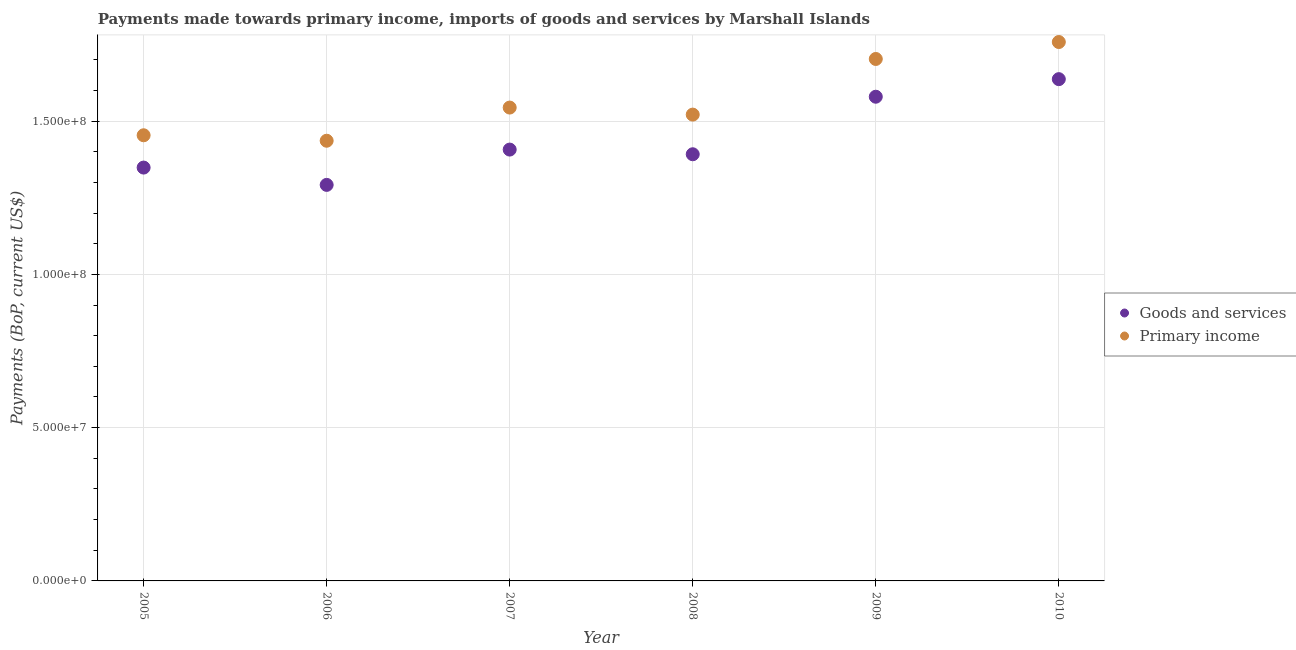How many different coloured dotlines are there?
Your answer should be compact. 2. What is the payments made towards primary income in 2010?
Keep it short and to the point. 1.76e+08. Across all years, what is the maximum payments made towards primary income?
Your answer should be very brief. 1.76e+08. Across all years, what is the minimum payments made towards primary income?
Make the answer very short. 1.44e+08. In which year was the payments made towards goods and services minimum?
Provide a short and direct response. 2006. What is the total payments made towards primary income in the graph?
Provide a succinct answer. 9.41e+08. What is the difference between the payments made towards goods and services in 2005 and that in 2007?
Keep it short and to the point. -5.87e+06. What is the difference between the payments made towards goods and services in 2010 and the payments made towards primary income in 2006?
Offer a very short reply. 2.01e+07. What is the average payments made towards goods and services per year?
Keep it short and to the point. 1.44e+08. In the year 2010, what is the difference between the payments made towards primary income and payments made towards goods and services?
Provide a short and direct response. 1.21e+07. In how many years, is the payments made towards primary income greater than 160000000 US$?
Make the answer very short. 2. What is the ratio of the payments made towards primary income in 2008 to that in 2009?
Give a very brief answer. 0.89. Is the payments made towards primary income in 2007 less than that in 2009?
Offer a very short reply. Yes. What is the difference between the highest and the second highest payments made towards goods and services?
Give a very brief answer. 5.73e+06. What is the difference between the highest and the lowest payments made towards goods and services?
Your response must be concise. 3.45e+07. In how many years, is the payments made towards primary income greater than the average payments made towards primary income taken over all years?
Give a very brief answer. 2. Is the sum of the payments made towards goods and services in 2008 and 2009 greater than the maximum payments made towards primary income across all years?
Give a very brief answer. Yes. Is the payments made towards primary income strictly less than the payments made towards goods and services over the years?
Ensure brevity in your answer.  No. How many dotlines are there?
Your answer should be very brief. 2. Are the values on the major ticks of Y-axis written in scientific E-notation?
Make the answer very short. Yes. Does the graph contain any zero values?
Give a very brief answer. No. Where does the legend appear in the graph?
Make the answer very short. Center right. How are the legend labels stacked?
Keep it short and to the point. Vertical. What is the title of the graph?
Give a very brief answer. Payments made towards primary income, imports of goods and services by Marshall Islands. Does "Investment" appear as one of the legend labels in the graph?
Your answer should be compact. No. What is the label or title of the X-axis?
Provide a short and direct response. Year. What is the label or title of the Y-axis?
Keep it short and to the point. Payments (BoP, current US$). What is the Payments (BoP, current US$) in Goods and services in 2005?
Offer a terse response. 1.35e+08. What is the Payments (BoP, current US$) in Primary income in 2005?
Your answer should be very brief. 1.45e+08. What is the Payments (BoP, current US$) of Goods and services in 2006?
Your answer should be very brief. 1.29e+08. What is the Payments (BoP, current US$) of Primary income in 2006?
Give a very brief answer. 1.44e+08. What is the Payments (BoP, current US$) in Goods and services in 2007?
Offer a terse response. 1.41e+08. What is the Payments (BoP, current US$) of Primary income in 2007?
Your response must be concise. 1.54e+08. What is the Payments (BoP, current US$) in Goods and services in 2008?
Provide a short and direct response. 1.39e+08. What is the Payments (BoP, current US$) in Primary income in 2008?
Give a very brief answer. 1.52e+08. What is the Payments (BoP, current US$) of Goods and services in 2009?
Offer a terse response. 1.58e+08. What is the Payments (BoP, current US$) in Primary income in 2009?
Your answer should be very brief. 1.70e+08. What is the Payments (BoP, current US$) of Goods and services in 2010?
Provide a short and direct response. 1.64e+08. What is the Payments (BoP, current US$) of Primary income in 2010?
Ensure brevity in your answer.  1.76e+08. Across all years, what is the maximum Payments (BoP, current US$) in Goods and services?
Keep it short and to the point. 1.64e+08. Across all years, what is the maximum Payments (BoP, current US$) of Primary income?
Ensure brevity in your answer.  1.76e+08. Across all years, what is the minimum Payments (BoP, current US$) of Goods and services?
Make the answer very short. 1.29e+08. Across all years, what is the minimum Payments (BoP, current US$) of Primary income?
Your answer should be compact. 1.44e+08. What is the total Payments (BoP, current US$) of Goods and services in the graph?
Offer a very short reply. 8.65e+08. What is the total Payments (BoP, current US$) in Primary income in the graph?
Offer a terse response. 9.41e+08. What is the difference between the Payments (BoP, current US$) of Goods and services in 2005 and that in 2006?
Provide a short and direct response. 5.65e+06. What is the difference between the Payments (BoP, current US$) of Primary income in 2005 and that in 2006?
Your response must be concise. 1.78e+06. What is the difference between the Payments (BoP, current US$) of Goods and services in 2005 and that in 2007?
Offer a terse response. -5.87e+06. What is the difference between the Payments (BoP, current US$) of Primary income in 2005 and that in 2007?
Provide a succinct answer. -9.04e+06. What is the difference between the Payments (BoP, current US$) of Goods and services in 2005 and that in 2008?
Offer a very short reply. -4.35e+06. What is the difference between the Payments (BoP, current US$) in Primary income in 2005 and that in 2008?
Your response must be concise. -6.74e+06. What is the difference between the Payments (BoP, current US$) of Goods and services in 2005 and that in 2009?
Keep it short and to the point. -2.31e+07. What is the difference between the Payments (BoP, current US$) of Primary income in 2005 and that in 2009?
Provide a succinct answer. -2.49e+07. What is the difference between the Payments (BoP, current US$) in Goods and services in 2005 and that in 2010?
Make the answer very short. -2.88e+07. What is the difference between the Payments (BoP, current US$) in Primary income in 2005 and that in 2010?
Keep it short and to the point. -3.04e+07. What is the difference between the Payments (BoP, current US$) in Goods and services in 2006 and that in 2007?
Your response must be concise. -1.15e+07. What is the difference between the Payments (BoP, current US$) in Primary income in 2006 and that in 2007?
Ensure brevity in your answer.  -1.08e+07. What is the difference between the Payments (BoP, current US$) in Goods and services in 2006 and that in 2008?
Keep it short and to the point. -9.99e+06. What is the difference between the Payments (BoP, current US$) of Primary income in 2006 and that in 2008?
Make the answer very short. -8.53e+06. What is the difference between the Payments (BoP, current US$) of Goods and services in 2006 and that in 2009?
Your response must be concise. -2.88e+07. What is the difference between the Payments (BoP, current US$) of Primary income in 2006 and that in 2009?
Offer a terse response. -2.67e+07. What is the difference between the Payments (BoP, current US$) in Goods and services in 2006 and that in 2010?
Ensure brevity in your answer.  -3.45e+07. What is the difference between the Payments (BoP, current US$) in Primary income in 2006 and that in 2010?
Ensure brevity in your answer.  -3.22e+07. What is the difference between the Payments (BoP, current US$) of Goods and services in 2007 and that in 2008?
Ensure brevity in your answer.  1.53e+06. What is the difference between the Payments (BoP, current US$) in Primary income in 2007 and that in 2008?
Ensure brevity in your answer.  2.30e+06. What is the difference between the Payments (BoP, current US$) of Goods and services in 2007 and that in 2009?
Provide a short and direct response. -1.72e+07. What is the difference between the Payments (BoP, current US$) of Primary income in 2007 and that in 2009?
Your answer should be very brief. -1.59e+07. What is the difference between the Payments (BoP, current US$) of Goods and services in 2007 and that in 2010?
Your response must be concise. -2.30e+07. What is the difference between the Payments (BoP, current US$) of Primary income in 2007 and that in 2010?
Your answer should be very brief. -2.14e+07. What is the difference between the Payments (BoP, current US$) in Goods and services in 2008 and that in 2009?
Make the answer very short. -1.88e+07. What is the difference between the Payments (BoP, current US$) of Primary income in 2008 and that in 2009?
Make the answer very short. -1.81e+07. What is the difference between the Payments (BoP, current US$) in Goods and services in 2008 and that in 2010?
Offer a very short reply. -2.45e+07. What is the difference between the Payments (BoP, current US$) of Primary income in 2008 and that in 2010?
Your answer should be very brief. -2.37e+07. What is the difference between the Payments (BoP, current US$) in Goods and services in 2009 and that in 2010?
Keep it short and to the point. -5.73e+06. What is the difference between the Payments (BoP, current US$) in Primary income in 2009 and that in 2010?
Your answer should be very brief. -5.53e+06. What is the difference between the Payments (BoP, current US$) of Goods and services in 2005 and the Payments (BoP, current US$) of Primary income in 2006?
Your answer should be compact. -8.75e+06. What is the difference between the Payments (BoP, current US$) of Goods and services in 2005 and the Payments (BoP, current US$) of Primary income in 2007?
Ensure brevity in your answer.  -1.96e+07. What is the difference between the Payments (BoP, current US$) of Goods and services in 2005 and the Payments (BoP, current US$) of Primary income in 2008?
Give a very brief answer. -1.73e+07. What is the difference between the Payments (BoP, current US$) in Goods and services in 2005 and the Payments (BoP, current US$) in Primary income in 2009?
Give a very brief answer. -3.54e+07. What is the difference between the Payments (BoP, current US$) in Goods and services in 2005 and the Payments (BoP, current US$) in Primary income in 2010?
Your answer should be compact. -4.10e+07. What is the difference between the Payments (BoP, current US$) in Goods and services in 2006 and the Payments (BoP, current US$) in Primary income in 2007?
Offer a very short reply. -2.52e+07. What is the difference between the Payments (BoP, current US$) in Goods and services in 2006 and the Payments (BoP, current US$) in Primary income in 2008?
Provide a short and direct response. -2.29e+07. What is the difference between the Payments (BoP, current US$) in Goods and services in 2006 and the Payments (BoP, current US$) in Primary income in 2009?
Make the answer very short. -4.11e+07. What is the difference between the Payments (BoP, current US$) of Goods and services in 2006 and the Payments (BoP, current US$) of Primary income in 2010?
Provide a succinct answer. -4.66e+07. What is the difference between the Payments (BoP, current US$) of Goods and services in 2007 and the Payments (BoP, current US$) of Primary income in 2008?
Keep it short and to the point. -1.14e+07. What is the difference between the Payments (BoP, current US$) in Goods and services in 2007 and the Payments (BoP, current US$) in Primary income in 2009?
Your answer should be very brief. -2.96e+07. What is the difference between the Payments (BoP, current US$) of Goods and services in 2007 and the Payments (BoP, current US$) of Primary income in 2010?
Your response must be concise. -3.51e+07. What is the difference between the Payments (BoP, current US$) in Goods and services in 2008 and the Payments (BoP, current US$) in Primary income in 2009?
Your answer should be very brief. -3.11e+07. What is the difference between the Payments (BoP, current US$) of Goods and services in 2008 and the Payments (BoP, current US$) of Primary income in 2010?
Offer a very short reply. -3.66e+07. What is the difference between the Payments (BoP, current US$) of Goods and services in 2009 and the Payments (BoP, current US$) of Primary income in 2010?
Provide a short and direct response. -1.78e+07. What is the average Payments (BoP, current US$) in Goods and services per year?
Your answer should be very brief. 1.44e+08. What is the average Payments (BoP, current US$) in Primary income per year?
Ensure brevity in your answer.  1.57e+08. In the year 2005, what is the difference between the Payments (BoP, current US$) in Goods and services and Payments (BoP, current US$) in Primary income?
Provide a short and direct response. -1.05e+07. In the year 2006, what is the difference between the Payments (BoP, current US$) of Goods and services and Payments (BoP, current US$) of Primary income?
Your answer should be very brief. -1.44e+07. In the year 2007, what is the difference between the Payments (BoP, current US$) of Goods and services and Payments (BoP, current US$) of Primary income?
Keep it short and to the point. -1.37e+07. In the year 2008, what is the difference between the Payments (BoP, current US$) of Goods and services and Payments (BoP, current US$) of Primary income?
Provide a succinct answer. -1.29e+07. In the year 2009, what is the difference between the Payments (BoP, current US$) of Goods and services and Payments (BoP, current US$) of Primary income?
Your answer should be very brief. -1.23e+07. In the year 2010, what is the difference between the Payments (BoP, current US$) of Goods and services and Payments (BoP, current US$) of Primary income?
Offer a terse response. -1.21e+07. What is the ratio of the Payments (BoP, current US$) in Goods and services in 2005 to that in 2006?
Make the answer very short. 1.04. What is the ratio of the Payments (BoP, current US$) of Primary income in 2005 to that in 2006?
Your answer should be compact. 1.01. What is the ratio of the Payments (BoP, current US$) in Goods and services in 2005 to that in 2007?
Provide a short and direct response. 0.96. What is the ratio of the Payments (BoP, current US$) in Primary income in 2005 to that in 2007?
Make the answer very short. 0.94. What is the ratio of the Payments (BoP, current US$) in Goods and services in 2005 to that in 2008?
Your answer should be very brief. 0.97. What is the ratio of the Payments (BoP, current US$) in Primary income in 2005 to that in 2008?
Keep it short and to the point. 0.96. What is the ratio of the Payments (BoP, current US$) of Goods and services in 2005 to that in 2009?
Offer a terse response. 0.85. What is the ratio of the Payments (BoP, current US$) in Primary income in 2005 to that in 2009?
Give a very brief answer. 0.85. What is the ratio of the Payments (BoP, current US$) in Goods and services in 2005 to that in 2010?
Ensure brevity in your answer.  0.82. What is the ratio of the Payments (BoP, current US$) in Primary income in 2005 to that in 2010?
Your answer should be very brief. 0.83. What is the ratio of the Payments (BoP, current US$) of Goods and services in 2006 to that in 2007?
Your answer should be compact. 0.92. What is the ratio of the Payments (BoP, current US$) of Primary income in 2006 to that in 2007?
Offer a very short reply. 0.93. What is the ratio of the Payments (BoP, current US$) of Goods and services in 2006 to that in 2008?
Your answer should be very brief. 0.93. What is the ratio of the Payments (BoP, current US$) of Primary income in 2006 to that in 2008?
Offer a very short reply. 0.94. What is the ratio of the Payments (BoP, current US$) of Goods and services in 2006 to that in 2009?
Offer a very short reply. 0.82. What is the ratio of the Payments (BoP, current US$) of Primary income in 2006 to that in 2009?
Your answer should be compact. 0.84. What is the ratio of the Payments (BoP, current US$) in Goods and services in 2006 to that in 2010?
Offer a terse response. 0.79. What is the ratio of the Payments (BoP, current US$) of Primary income in 2006 to that in 2010?
Provide a short and direct response. 0.82. What is the ratio of the Payments (BoP, current US$) of Primary income in 2007 to that in 2008?
Your answer should be compact. 1.02. What is the ratio of the Payments (BoP, current US$) of Goods and services in 2007 to that in 2009?
Provide a succinct answer. 0.89. What is the ratio of the Payments (BoP, current US$) in Primary income in 2007 to that in 2009?
Your answer should be compact. 0.91. What is the ratio of the Payments (BoP, current US$) in Goods and services in 2007 to that in 2010?
Provide a succinct answer. 0.86. What is the ratio of the Payments (BoP, current US$) in Primary income in 2007 to that in 2010?
Provide a short and direct response. 0.88. What is the ratio of the Payments (BoP, current US$) in Goods and services in 2008 to that in 2009?
Keep it short and to the point. 0.88. What is the ratio of the Payments (BoP, current US$) in Primary income in 2008 to that in 2009?
Make the answer very short. 0.89. What is the ratio of the Payments (BoP, current US$) in Goods and services in 2008 to that in 2010?
Offer a terse response. 0.85. What is the ratio of the Payments (BoP, current US$) in Primary income in 2008 to that in 2010?
Provide a short and direct response. 0.87. What is the ratio of the Payments (BoP, current US$) of Primary income in 2009 to that in 2010?
Give a very brief answer. 0.97. What is the difference between the highest and the second highest Payments (BoP, current US$) in Goods and services?
Make the answer very short. 5.73e+06. What is the difference between the highest and the second highest Payments (BoP, current US$) in Primary income?
Your answer should be very brief. 5.53e+06. What is the difference between the highest and the lowest Payments (BoP, current US$) in Goods and services?
Ensure brevity in your answer.  3.45e+07. What is the difference between the highest and the lowest Payments (BoP, current US$) of Primary income?
Your answer should be compact. 3.22e+07. 